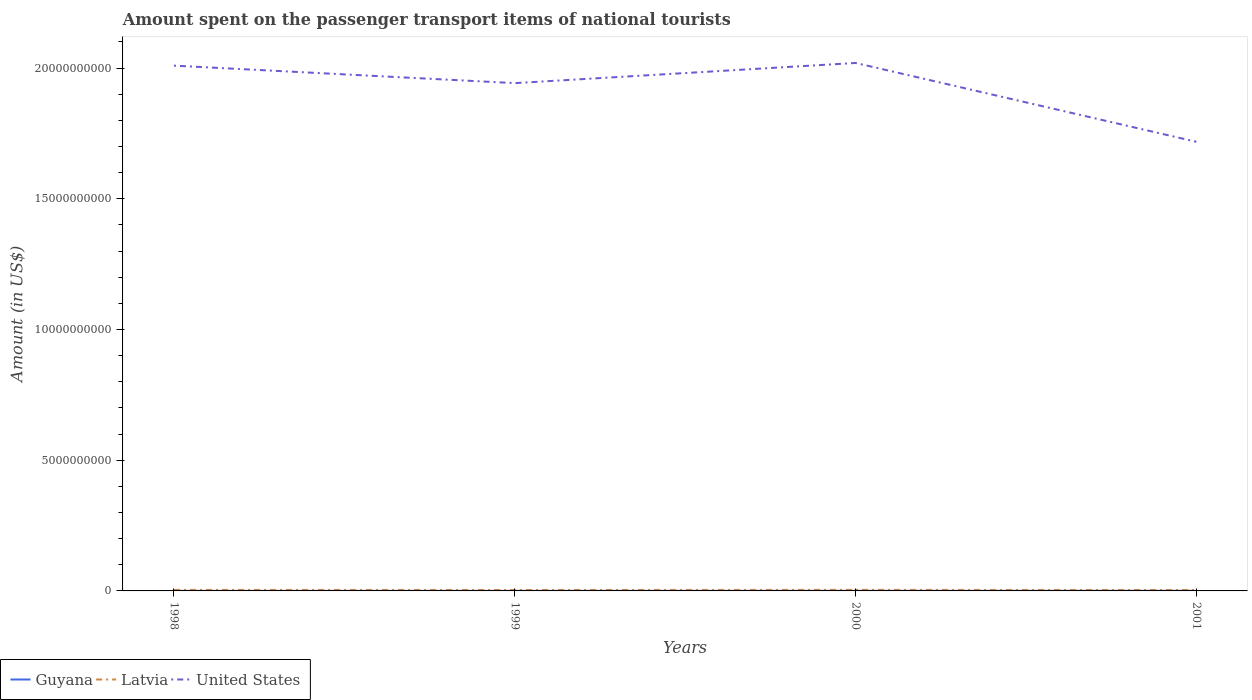How many different coloured lines are there?
Your answer should be compact. 3. Across all years, what is the maximum amount spent on the passenger transport items of national tourists in United States?
Ensure brevity in your answer.  1.72e+1. In which year was the amount spent on the passenger transport items of national tourists in Guyana maximum?
Your answer should be very brief. 1998. What is the total amount spent on the passenger transport items of national tourists in Latvia in the graph?
Provide a succinct answer. 7.00e+06. What is the difference between the highest and the second highest amount spent on the passenger transport items of national tourists in Latvia?
Provide a short and direct response. 7.00e+06. How many lines are there?
Keep it short and to the point. 3. What is the difference between two consecutive major ticks on the Y-axis?
Offer a terse response. 5.00e+09. Does the graph contain any zero values?
Give a very brief answer. No. Does the graph contain grids?
Your answer should be very brief. No. Where does the legend appear in the graph?
Your answer should be compact. Bottom left. How many legend labels are there?
Ensure brevity in your answer.  3. What is the title of the graph?
Give a very brief answer. Amount spent on the passenger transport items of national tourists. What is the label or title of the Y-axis?
Offer a very short reply. Amount (in US$). What is the Amount (in US$) in Guyana in 1998?
Your answer should be compact. 3.00e+06. What is the Amount (in US$) in Latvia in 1998?
Offer a very short reply. 4.00e+07. What is the Amount (in US$) of United States in 1998?
Give a very brief answer. 2.01e+1. What is the Amount (in US$) of Latvia in 1999?
Offer a terse response. 3.50e+07. What is the Amount (in US$) in United States in 1999?
Keep it short and to the point. 1.94e+1. What is the Amount (in US$) of Guyana in 2000?
Your response must be concise. 5.00e+06. What is the Amount (in US$) of Latvia in 2000?
Keep it short and to the point. 4.10e+07. What is the Amount (in US$) in United States in 2000?
Your answer should be compact. 2.02e+1. What is the Amount (in US$) in Latvia in 2001?
Offer a terse response. 3.40e+07. What is the Amount (in US$) in United States in 2001?
Keep it short and to the point. 1.72e+1. Across all years, what is the maximum Amount (in US$) in Guyana?
Offer a very short reply. 5.00e+06. Across all years, what is the maximum Amount (in US$) in Latvia?
Give a very brief answer. 4.10e+07. Across all years, what is the maximum Amount (in US$) in United States?
Your answer should be very brief. 2.02e+1. Across all years, what is the minimum Amount (in US$) in Latvia?
Your answer should be compact. 3.40e+07. Across all years, what is the minimum Amount (in US$) in United States?
Your answer should be compact. 1.72e+1. What is the total Amount (in US$) of Guyana in the graph?
Offer a terse response. 1.50e+07. What is the total Amount (in US$) of Latvia in the graph?
Offer a terse response. 1.50e+08. What is the total Amount (in US$) of United States in the graph?
Ensure brevity in your answer.  7.69e+1. What is the difference between the Amount (in US$) of Guyana in 1998 and that in 1999?
Your answer should be compact. 0. What is the difference between the Amount (in US$) in Latvia in 1998 and that in 1999?
Keep it short and to the point. 5.00e+06. What is the difference between the Amount (in US$) of United States in 1998 and that in 1999?
Ensure brevity in your answer.  6.69e+08. What is the difference between the Amount (in US$) of Guyana in 1998 and that in 2000?
Provide a succinct answer. -2.00e+06. What is the difference between the Amount (in US$) in Latvia in 1998 and that in 2000?
Provide a short and direct response. -1.00e+06. What is the difference between the Amount (in US$) of United States in 1998 and that in 2000?
Ensure brevity in your answer.  -1.02e+08. What is the difference between the Amount (in US$) of Guyana in 1998 and that in 2001?
Give a very brief answer. -1.00e+06. What is the difference between the Amount (in US$) of United States in 1998 and that in 2001?
Make the answer very short. 2.91e+09. What is the difference between the Amount (in US$) in Latvia in 1999 and that in 2000?
Keep it short and to the point. -6.00e+06. What is the difference between the Amount (in US$) in United States in 1999 and that in 2000?
Offer a very short reply. -7.71e+08. What is the difference between the Amount (in US$) of Guyana in 1999 and that in 2001?
Offer a terse response. -1.00e+06. What is the difference between the Amount (in US$) of Latvia in 1999 and that in 2001?
Keep it short and to the point. 1.00e+06. What is the difference between the Amount (in US$) in United States in 1999 and that in 2001?
Provide a succinct answer. 2.24e+09. What is the difference between the Amount (in US$) of Guyana in 2000 and that in 2001?
Keep it short and to the point. 1.00e+06. What is the difference between the Amount (in US$) in Latvia in 2000 and that in 2001?
Provide a succinct answer. 7.00e+06. What is the difference between the Amount (in US$) of United States in 2000 and that in 2001?
Your answer should be very brief. 3.02e+09. What is the difference between the Amount (in US$) in Guyana in 1998 and the Amount (in US$) in Latvia in 1999?
Provide a succinct answer. -3.20e+07. What is the difference between the Amount (in US$) in Guyana in 1998 and the Amount (in US$) in United States in 1999?
Ensure brevity in your answer.  -1.94e+1. What is the difference between the Amount (in US$) in Latvia in 1998 and the Amount (in US$) in United States in 1999?
Your answer should be compact. -1.94e+1. What is the difference between the Amount (in US$) of Guyana in 1998 and the Amount (in US$) of Latvia in 2000?
Ensure brevity in your answer.  -3.80e+07. What is the difference between the Amount (in US$) in Guyana in 1998 and the Amount (in US$) in United States in 2000?
Ensure brevity in your answer.  -2.02e+1. What is the difference between the Amount (in US$) in Latvia in 1998 and the Amount (in US$) in United States in 2000?
Your response must be concise. -2.02e+1. What is the difference between the Amount (in US$) of Guyana in 1998 and the Amount (in US$) of Latvia in 2001?
Make the answer very short. -3.10e+07. What is the difference between the Amount (in US$) of Guyana in 1998 and the Amount (in US$) of United States in 2001?
Provide a succinct answer. -1.72e+1. What is the difference between the Amount (in US$) of Latvia in 1998 and the Amount (in US$) of United States in 2001?
Ensure brevity in your answer.  -1.71e+1. What is the difference between the Amount (in US$) of Guyana in 1999 and the Amount (in US$) of Latvia in 2000?
Your response must be concise. -3.80e+07. What is the difference between the Amount (in US$) in Guyana in 1999 and the Amount (in US$) in United States in 2000?
Your response must be concise. -2.02e+1. What is the difference between the Amount (in US$) of Latvia in 1999 and the Amount (in US$) of United States in 2000?
Your response must be concise. -2.02e+1. What is the difference between the Amount (in US$) in Guyana in 1999 and the Amount (in US$) in Latvia in 2001?
Give a very brief answer. -3.10e+07. What is the difference between the Amount (in US$) of Guyana in 1999 and the Amount (in US$) of United States in 2001?
Provide a short and direct response. -1.72e+1. What is the difference between the Amount (in US$) of Latvia in 1999 and the Amount (in US$) of United States in 2001?
Your response must be concise. -1.71e+1. What is the difference between the Amount (in US$) in Guyana in 2000 and the Amount (in US$) in Latvia in 2001?
Your response must be concise. -2.90e+07. What is the difference between the Amount (in US$) of Guyana in 2000 and the Amount (in US$) of United States in 2001?
Your response must be concise. -1.72e+1. What is the difference between the Amount (in US$) in Latvia in 2000 and the Amount (in US$) in United States in 2001?
Give a very brief answer. -1.71e+1. What is the average Amount (in US$) of Guyana per year?
Your response must be concise. 3.75e+06. What is the average Amount (in US$) in Latvia per year?
Your answer should be compact. 3.75e+07. What is the average Amount (in US$) in United States per year?
Offer a terse response. 1.92e+1. In the year 1998, what is the difference between the Amount (in US$) in Guyana and Amount (in US$) in Latvia?
Your answer should be compact. -3.70e+07. In the year 1998, what is the difference between the Amount (in US$) in Guyana and Amount (in US$) in United States?
Provide a short and direct response. -2.01e+1. In the year 1998, what is the difference between the Amount (in US$) in Latvia and Amount (in US$) in United States?
Make the answer very short. -2.01e+1. In the year 1999, what is the difference between the Amount (in US$) of Guyana and Amount (in US$) of Latvia?
Your response must be concise. -3.20e+07. In the year 1999, what is the difference between the Amount (in US$) in Guyana and Amount (in US$) in United States?
Your answer should be compact. -1.94e+1. In the year 1999, what is the difference between the Amount (in US$) in Latvia and Amount (in US$) in United States?
Offer a very short reply. -1.94e+1. In the year 2000, what is the difference between the Amount (in US$) of Guyana and Amount (in US$) of Latvia?
Your answer should be compact. -3.60e+07. In the year 2000, what is the difference between the Amount (in US$) in Guyana and Amount (in US$) in United States?
Keep it short and to the point. -2.02e+1. In the year 2000, what is the difference between the Amount (in US$) in Latvia and Amount (in US$) in United States?
Keep it short and to the point. -2.02e+1. In the year 2001, what is the difference between the Amount (in US$) of Guyana and Amount (in US$) of Latvia?
Make the answer very short. -3.00e+07. In the year 2001, what is the difference between the Amount (in US$) in Guyana and Amount (in US$) in United States?
Offer a terse response. -1.72e+1. In the year 2001, what is the difference between the Amount (in US$) in Latvia and Amount (in US$) in United States?
Make the answer very short. -1.71e+1. What is the ratio of the Amount (in US$) in Guyana in 1998 to that in 1999?
Offer a very short reply. 1. What is the ratio of the Amount (in US$) of Latvia in 1998 to that in 1999?
Make the answer very short. 1.14. What is the ratio of the Amount (in US$) of United States in 1998 to that in 1999?
Keep it short and to the point. 1.03. What is the ratio of the Amount (in US$) in Guyana in 1998 to that in 2000?
Keep it short and to the point. 0.6. What is the ratio of the Amount (in US$) in Latvia in 1998 to that in 2000?
Provide a succinct answer. 0.98. What is the ratio of the Amount (in US$) in Guyana in 1998 to that in 2001?
Your response must be concise. 0.75. What is the ratio of the Amount (in US$) of Latvia in 1998 to that in 2001?
Your answer should be compact. 1.18. What is the ratio of the Amount (in US$) in United States in 1998 to that in 2001?
Provide a short and direct response. 1.17. What is the ratio of the Amount (in US$) in Latvia in 1999 to that in 2000?
Your answer should be compact. 0.85. What is the ratio of the Amount (in US$) in United States in 1999 to that in 2000?
Your answer should be compact. 0.96. What is the ratio of the Amount (in US$) of Latvia in 1999 to that in 2001?
Ensure brevity in your answer.  1.03. What is the ratio of the Amount (in US$) of United States in 1999 to that in 2001?
Ensure brevity in your answer.  1.13. What is the ratio of the Amount (in US$) of Latvia in 2000 to that in 2001?
Your answer should be compact. 1.21. What is the ratio of the Amount (in US$) in United States in 2000 to that in 2001?
Offer a very short reply. 1.18. What is the difference between the highest and the second highest Amount (in US$) in Guyana?
Your answer should be very brief. 1.00e+06. What is the difference between the highest and the second highest Amount (in US$) of Latvia?
Make the answer very short. 1.00e+06. What is the difference between the highest and the second highest Amount (in US$) of United States?
Your response must be concise. 1.02e+08. What is the difference between the highest and the lowest Amount (in US$) in United States?
Keep it short and to the point. 3.02e+09. 